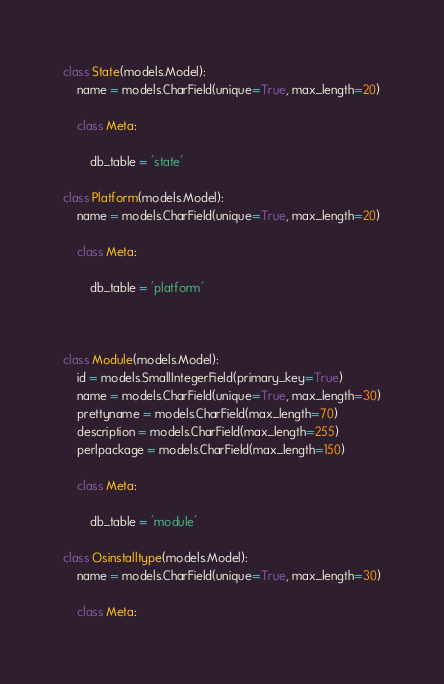<code> <loc_0><loc_0><loc_500><loc_500><_Python_>class State(models.Model):
    name = models.CharField(unique=True, max_length=20)

    class Meta:
        
        db_table = 'state'

class Platform(models.Model):
    name = models.CharField(unique=True, max_length=20)

    class Meta:
        
        db_table = 'platform'



class Module(models.Model):
    id = models.SmallIntegerField(primary_key=True)
    name = models.CharField(unique=True, max_length=30)
    prettyname = models.CharField(max_length=70)
    description = models.CharField(max_length=255)
    perlpackage = models.CharField(max_length=150)

    class Meta:
        
        db_table = 'module'
        
class Osinstalltype(models.Model):
    name = models.CharField(unique=True, max_length=30)

    class Meta:</code> 